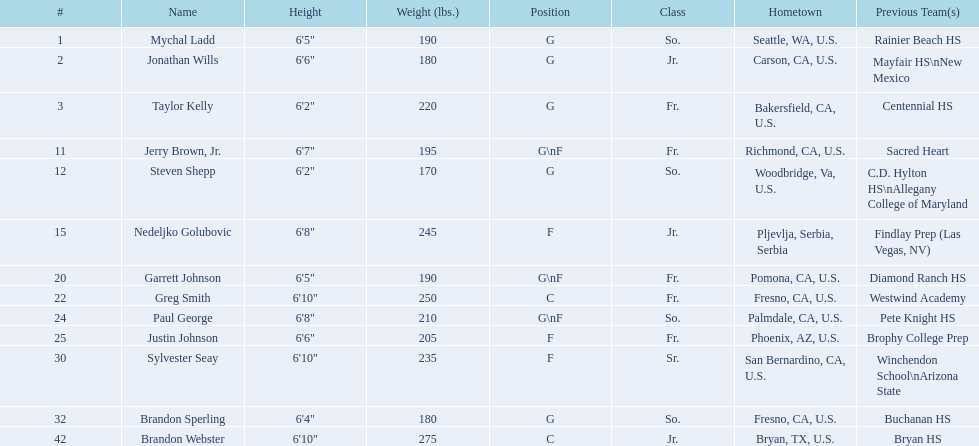Who makes up the 2009-10 fresno state bulldogs men's basketball team? Mychal Ladd, Jonathan Wills, Taylor Kelly, Jerry Brown, Jr., Steven Shepp, Nedeljko Golubovic, Garrett Johnson, Greg Smith, Paul George, Justin Johnson, Sylvester Seay, Brandon Sperling, Brandon Webster. Within this roster, who are the athletes playing as forwards? Jerry Brown, Jr., Nedeljko Golubovic, Garrett Johnson, Paul George, Justin Johnson, Sylvester Seay. Who among them only occupies the forward position and not any others? Nedeljko Golubovic, Justin Johnson, Sylvester Seay. From these players, who has the shortest stature? Justin Johnson. 